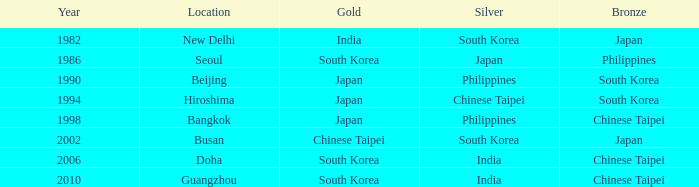Which Location has a Silver of japan? Seoul. 